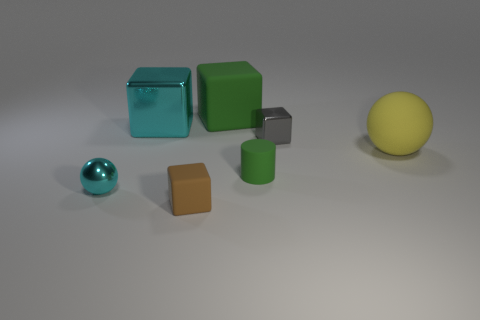Subtract all large green blocks. How many blocks are left? 3 Add 3 gray shiny cubes. How many objects exist? 10 Subtract all gray cubes. How many cubes are left? 3 Subtract 2 balls. How many balls are left? 0 Subtract 0 cyan cylinders. How many objects are left? 7 Subtract all cylinders. How many objects are left? 6 Subtract all brown spheres. Subtract all red cubes. How many spheres are left? 2 Subtract all large green shiny objects. Subtract all green blocks. How many objects are left? 6 Add 7 brown matte objects. How many brown matte objects are left? 8 Add 4 green things. How many green things exist? 6 